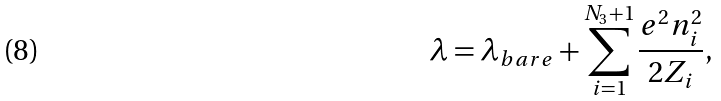<formula> <loc_0><loc_0><loc_500><loc_500>\lambda = \lambda _ { b a r e } + \sum _ { i = 1 } ^ { N _ { 3 } + 1 } \frac { e ^ { 2 } n _ { i } ^ { 2 } } { 2 Z _ { i } } ,</formula> 